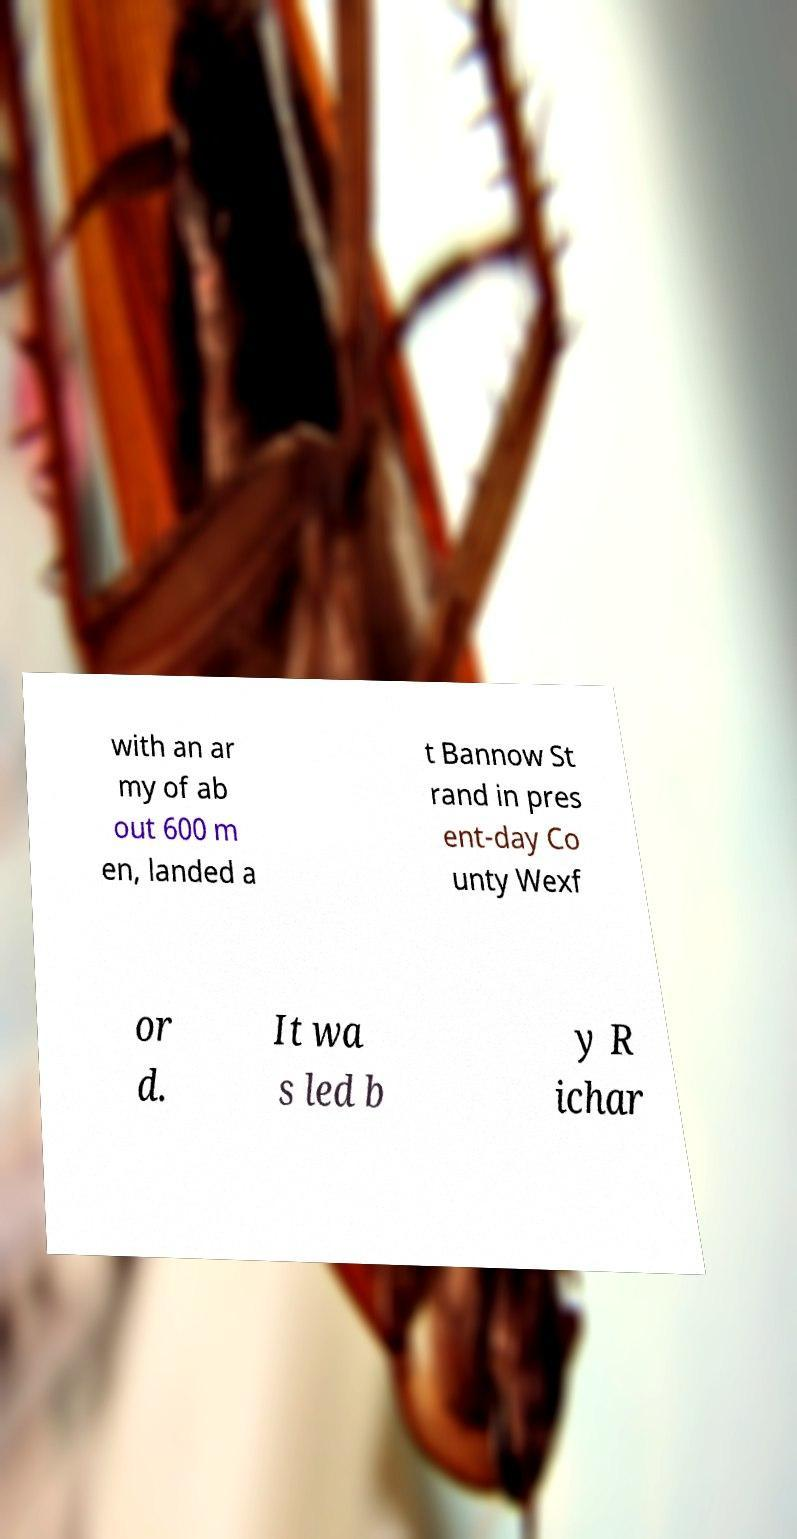For documentation purposes, I need the text within this image transcribed. Could you provide that? with an ar my of ab out 600 m en, landed a t Bannow St rand in pres ent-day Co unty Wexf or d. It wa s led b y R ichar 